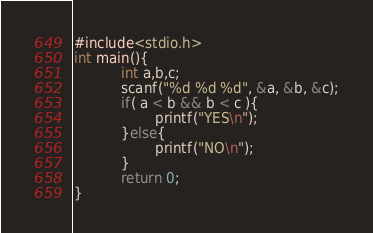Convert code to text. <code><loc_0><loc_0><loc_500><loc_500><_C_>#include<stdio.h>
int main(){
           int a,b,c;
           scanf("%d %d %d", &a, &b, &c);
           if( a < b && b < c ){
                   printf("YES\n");
           }else{
                   printf("NO\n");
           }
           return 0;
}</code> 